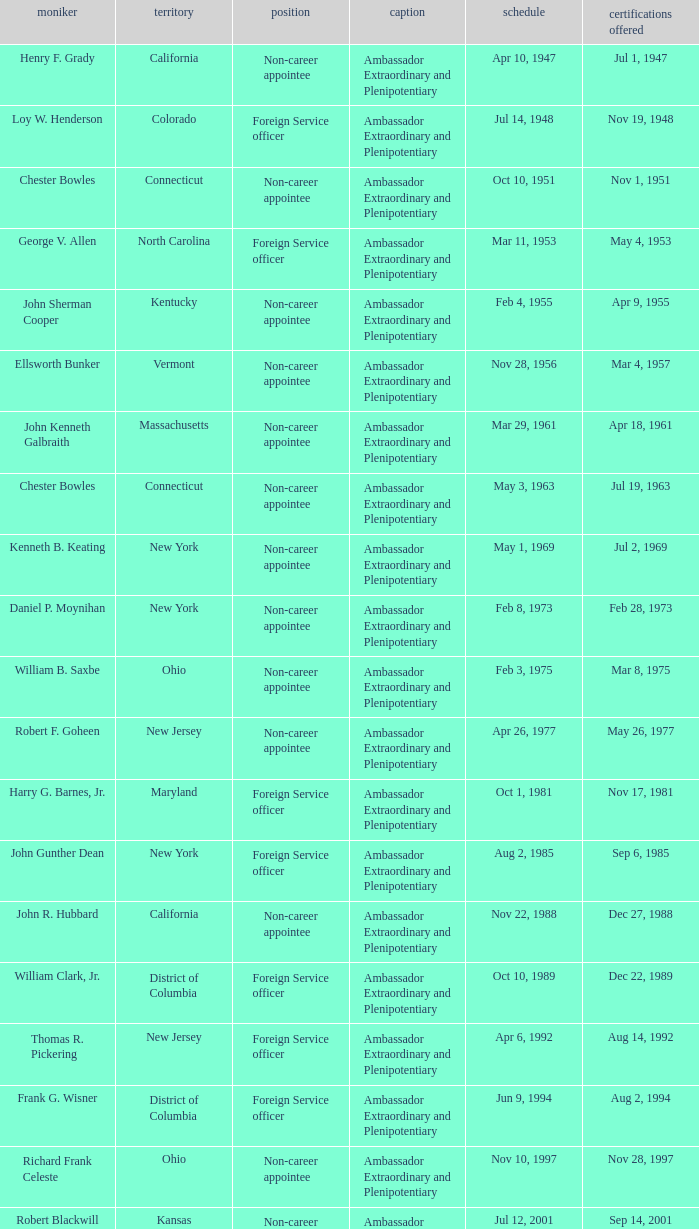When were the credentials presented for new jersey with a status of foreign service officer? Aug 14, 1992. 